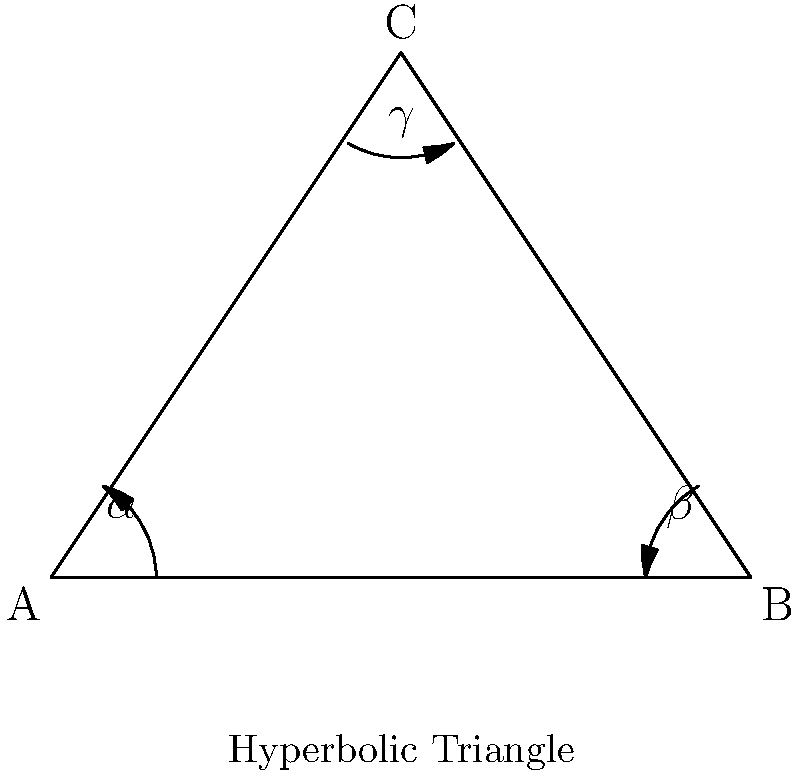In a hyperbolic triangle ABC, as shown in the figure, the angles are denoted by $\alpha$, $\beta$, and $\gamma$. What is the relationship between the sum of these angles and a straight angle (180°) in hyperbolic geometry? To understand the sum of angles in a hyperbolic triangle, let's follow these steps:

1) In Euclidean geometry, we know that the sum of angles in a triangle is always 180°. However, this is not the case in hyperbolic geometry.

2) In hyperbolic geometry, the sum of angles in a triangle is always less than 180°. This is one of the fundamental differences between Euclidean and hyperbolic geometries.

3) The relationship can be expressed as:

   $$\alpha + \beta + \gamma < 180°$$

4) The difference between 180° and the sum of the angles is called the defect of the triangle. Let's denote this defect as $\delta$:

   $$\delta = 180° - (\alpha + \beta + \gamma)$$

5) In hyperbolic geometry, this defect $\delta$ is always positive.

6) Interestingly, in hyperbolic geometry, the defect is proportional to the area of the triangle. This means that larger hyperbolic triangles have a greater defect, and thus a smaller sum of angles.

7) This property is in stark contrast to Euclidean geometry, where the sum of angles is constant regardless of the triangle's size.

Understanding this concept is crucial for development practitioners working on projects that involve non-Euclidean geometries, such as in certain mapping or spatial analysis applications.
Answer: $\alpha + \beta + \gamma < 180°$ 